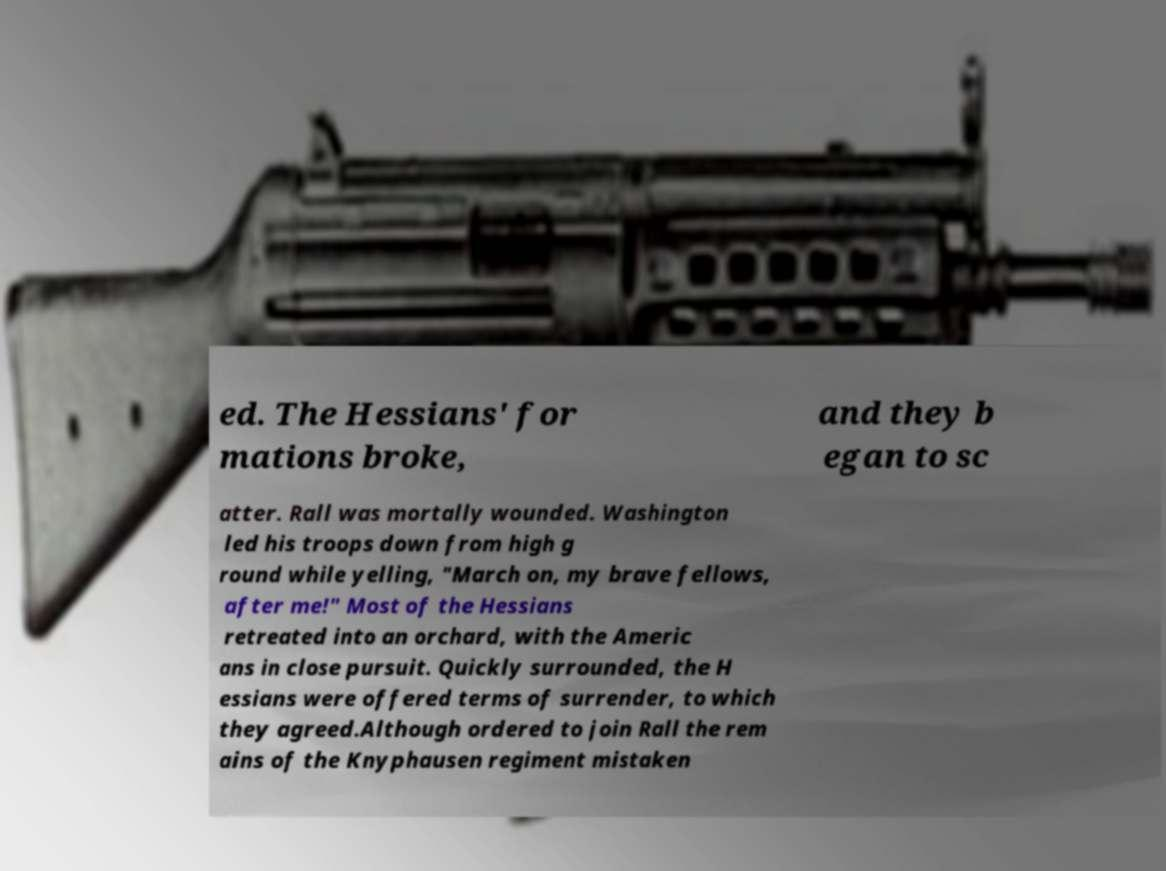Could you extract and type out the text from this image? ed. The Hessians' for mations broke, and they b egan to sc atter. Rall was mortally wounded. Washington led his troops down from high g round while yelling, "March on, my brave fellows, after me!" Most of the Hessians retreated into an orchard, with the Americ ans in close pursuit. Quickly surrounded, the H essians were offered terms of surrender, to which they agreed.Although ordered to join Rall the rem ains of the Knyphausen regiment mistaken 